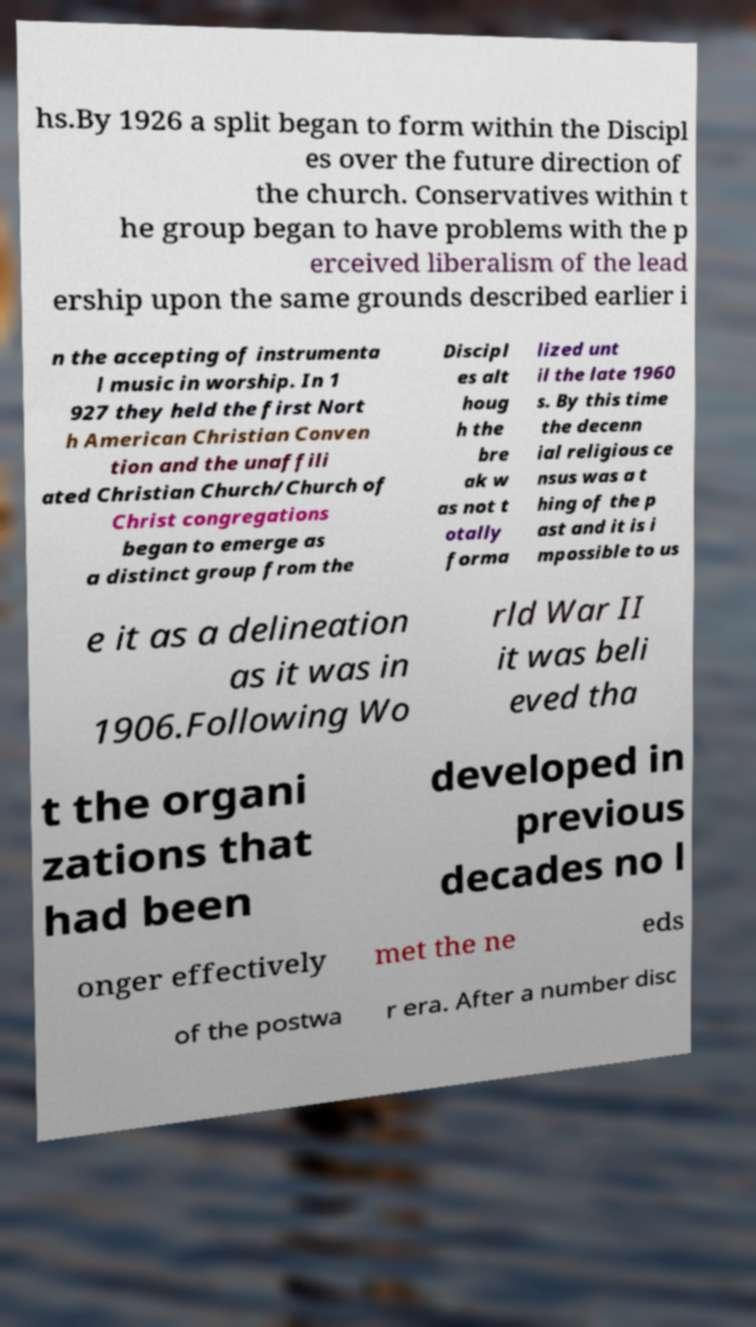There's text embedded in this image that I need extracted. Can you transcribe it verbatim? hs.By 1926 a split began to form within the Discipl es over the future direction of the church. Conservatives within t he group began to have problems with the p erceived liberalism of the lead ership upon the same grounds described earlier i n the accepting of instrumenta l music in worship. In 1 927 they held the first Nort h American Christian Conven tion and the unaffili ated Christian Church/Church of Christ congregations began to emerge as a distinct group from the Discipl es alt houg h the bre ak w as not t otally forma lized unt il the late 1960 s. By this time the decenn ial religious ce nsus was a t hing of the p ast and it is i mpossible to us e it as a delineation as it was in 1906.Following Wo rld War II it was beli eved tha t the organi zations that had been developed in previous decades no l onger effectively met the ne eds of the postwa r era. After a number disc 